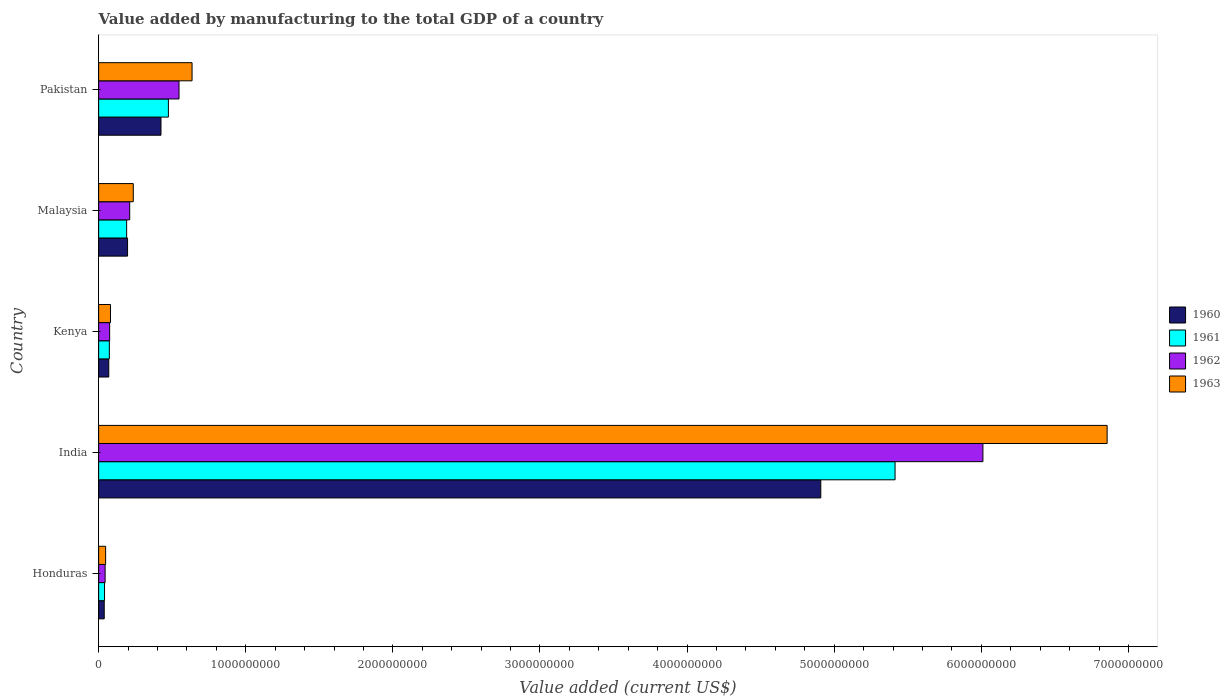How many different coloured bars are there?
Offer a very short reply. 4. How many groups of bars are there?
Provide a succinct answer. 5. How many bars are there on the 1st tick from the bottom?
Provide a short and direct response. 4. What is the label of the 2nd group of bars from the top?
Your answer should be compact. Malaysia. What is the value added by manufacturing to the total GDP in 1962 in Pakistan?
Make the answer very short. 5.46e+08. Across all countries, what is the maximum value added by manufacturing to the total GDP in 1960?
Keep it short and to the point. 4.91e+09. Across all countries, what is the minimum value added by manufacturing to the total GDP in 1961?
Keep it short and to the point. 4.00e+07. In which country was the value added by manufacturing to the total GDP in 1960 minimum?
Make the answer very short. Honduras. What is the total value added by manufacturing to the total GDP in 1961 in the graph?
Ensure brevity in your answer.  6.19e+09. What is the difference between the value added by manufacturing to the total GDP in 1963 in Kenya and that in Pakistan?
Your answer should be very brief. -5.54e+08. What is the difference between the value added by manufacturing to the total GDP in 1961 in Malaysia and the value added by manufacturing to the total GDP in 1960 in Kenya?
Make the answer very short. 1.21e+08. What is the average value added by manufacturing to the total GDP in 1962 per country?
Provide a succinct answer. 1.38e+09. What is the difference between the value added by manufacturing to the total GDP in 1962 and value added by manufacturing to the total GDP in 1963 in Malaysia?
Provide a short and direct response. -2.43e+07. In how many countries, is the value added by manufacturing to the total GDP in 1962 greater than 1600000000 US$?
Provide a succinct answer. 1. What is the ratio of the value added by manufacturing to the total GDP in 1960 in India to that in Malaysia?
Keep it short and to the point. 24.96. Is the value added by manufacturing to the total GDP in 1960 in India less than that in Pakistan?
Offer a terse response. No. What is the difference between the highest and the second highest value added by manufacturing to the total GDP in 1963?
Make the answer very short. 6.22e+09. What is the difference between the highest and the lowest value added by manufacturing to the total GDP in 1961?
Your answer should be very brief. 5.37e+09. What does the 3rd bar from the top in Pakistan represents?
Offer a terse response. 1961. What does the 2nd bar from the bottom in India represents?
Ensure brevity in your answer.  1961. Is it the case that in every country, the sum of the value added by manufacturing to the total GDP in 1961 and value added by manufacturing to the total GDP in 1963 is greater than the value added by manufacturing to the total GDP in 1962?
Provide a short and direct response. Yes. How many bars are there?
Keep it short and to the point. 20. How many countries are there in the graph?
Ensure brevity in your answer.  5. Does the graph contain any zero values?
Offer a terse response. No. Where does the legend appear in the graph?
Your answer should be compact. Center right. How many legend labels are there?
Offer a very short reply. 4. How are the legend labels stacked?
Your answer should be very brief. Vertical. What is the title of the graph?
Offer a very short reply. Value added by manufacturing to the total GDP of a country. What is the label or title of the X-axis?
Keep it short and to the point. Value added (current US$). What is the Value added (current US$) of 1960 in Honduras?
Give a very brief answer. 3.80e+07. What is the Value added (current US$) in 1961 in Honduras?
Your response must be concise. 4.00e+07. What is the Value added (current US$) of 1962 in Honduras?
Provide a succinct answer. 4.41e+07. What is the Value added (current US$) in 1963 in Honduras?
Keep it short and to the point. 4.76e+07. What is the Value added (current US$) of 1960 in India?
Provide a succinct answer. 4.91e+09. What is the Value added (current US$) in 1961 in India?
Make the answer very short. 5.41e+09. What is the Value added (current US$) in 1962 in India?
Provide a succinct answer. 6.01e+09. What is the Value added (current US$) in 1963 in India?
Offer a very short reply. 6.85e+09. What is the Value added (current US$) in 1960 in Kenya?
Provide a short and direct response. 6.89e+07. What is the Value added (current US$) in 1961 in Kenya?
Your answer should be very brief. 7.28e+07. What is the Value added (current US$) of 1962 in Kenya?
Offer a terse response. 7.48e+07. What is the Value added (current US$) in 1963 in Kenya?
Make the answer very short. 8.05e+07. What is the Value added (current US$) in 1960 in Malaysia?
Give a very brief answer. 1.97e+08. What is the Value added (current US$) in 1961 in Malaysia?
Your answer should be very brief. 1.90e+08. What is the Value added (current US$) in 1962 in Malaysia?
Your answer should be very brief. 2.11e+08. What is the Value added (current US$) of 1963 in Malaysia?
Provide a succinct answer. 2.36e+08. What is the Value added (current US$) in 1960 in Pakistan?
Ensure brevity in your answer.  4.24e+08. What is the Value added (current US$) in 1961 in Pakistan?
Make the answer very short. 4.74e+08. What is the Value added (current US$) of 1962 in Pakistan?
Give a very brief answer. 5.46e+08. What is the Value added (current US$) in 1963 in Pakistan?
Give a very brief answer. 6.35e+08. Across all countries, what is the maximum Value added (current US$) of 1960?
Your answer should be very brief. 4.91e+09. Across all countries, what is the maximum Value added (current US$) of 1961?
Make the answer very short. 5.41e+09. Across all countries, what is the maximum Value added (current US$) in 1962?
Keep it short and to the point. 6.01e+09. Across all countries, what is the maximum Value added (current US$) of 1963?
Provide a short and direct response. 6.85e+09. Across all countries, what is the minimum Value added (current US$) in 1960?
Offer a terse response. 3.80e+07. Across all countries, what is the minimum Value added (current US$) in 1961?
Offer a terse response. 4.00e+07. Across all countries, what is the minimum Value added (current US$) in 1962?
Offer a very short reply. 4.41e+07. Across all countries, what is the minimum Value added (current US$) in 1963?
Provide a succinct answer. 4.76e+07. What is the total Value added (current US$) of 1960 in the graph?
Offer a terse response. 5.64e+09. What is the total Value added (current US$) of 1961 in the graph?
Keep it short and to the point. 6.19e+09. What is the total Value added (current US$) in 1962 in the graph?
Provide a short and direct response. 6.89e+09. What is the total Value added (current US$) in 1963 in the graph?
Ensure brevity in your answer.  7.85e+09. What is the difference between the Value added (current US$) in 1960 in Honduras and that in India?
Your response must be concise. -4.87e+09. What is the difference between the Value added (current US$) in 1961 in Honduras and that in India?
Provide a short and direct response. -5.37e+09. What is the difference between the Value added (current US$) in 1962 in Honduras and that in India?
Your answer should be compact. -5.97e+09. What is the difference between the Value added (current US$) of 1963 in Honduras and that in India?
Offer a terse response. -6.81e+09. What is the difference between the Value added (current US$) in 1960 in Honduras and that in Kenya?
Make the answer very short. -3.09e+07. What is the difference between the Value added (current US$) in 1961 in Honduras and that in Kenya?
Your answer should be compact. -3.28e+07. What is the difference between the Value added (current US$) of 1962 in Honduras and that in Kenya?
Your answer should be very brief. -3.07e+07. What is the difference between the Value added (current US$) in 1963 in Honduras and that in Kenya?
Offer a terse response. -3.30e+07. What is the difference between the Value added (current US$) in 1960 in Honduras and that in Malaysia?
Make the answer very short. -1.59e+08. What is the difference between the Value added (current US$) in 1961 in Honduras and that in Malaysia?
Your answer should be compact. -1.50e+08. What is the difference between the Value added (current US$) in 1962 in Honduras and that in Malaysia?
Offer a terse response. -1.67e+08. What is the difference between the Value added (current US$) of 1963 in Honduras and that in Malaysia?
Offer a terse response. -1.88e+08. What is the difference between the Value added (current US$) of 1960 in Honduras and that in Pakistan?
Your answer should be compact. -3.86e+08. What is the difference between the Value added (current US$) of 1961 in Honduras and that in Pakistan?
Offer a terse response. -4.34e+08. What is the difference between the Value added (current US$) of 1962 in Honduras and that in Pakistan?
Offer a very short reply. -5.02e+08. What is the difference between the Value added (current US$) of 1963 in Honduras and that in Pakistan?
Provide a short and direct response. -5.87e+08. What is the difference between the Value added (current US$) in 1960 in India and that in Kenya?
Your answer should be very brief. 4.84e+09. What is the difference between the Value added (current US$) in 1961 in India and that in Kenya?
Give a very brief answer. 5.34e+09. What is the difference between the Value added (current US$) in 1962 in India and that in Kenya?
Keep it short and to the point. 5.94e+09. What is the difference between the Value added (current US$) in 1963 in India and that in Kenya?
Ensure brevity in your answer.  6.77e+09. What is the difference between the Value added (current US$) of 1960 in India and that in Malaysia?
Your answer should be very brief. 4.71e+09. What is the difference between the Value added (current US$) of 1961 in India and that in Malaysia?
Ensure brevity in your answer.  5.22e+09. What is the difference between the Value added (current US$) in 1962 in India and that in Malaysia?
Make the answer very short. 5.80e+09. What is the difference between the Value added (current US$) of 1963 in India and that in Malaysia?
Offer a very short reply. 6.62e+09. What is the difference between the Value added (current US$) in 1960 in India and that in Pakistan?
Offer a very short reply. 4.48e+09. What is the difference between the Value added (current US$) in 1961 in India and that in Pakistan?
Give a very brief answer. 4.94e+09. What is the difference between the Value added (current US$) of 1962 in India and that in Pakistan?
Ensure brevity in your answer.  5.46e+09. What is the difference between the Value added (current US$) of 1963 in India and that in Pakistan?
Give a very brief answer. 6.22e+09. What is the difference between the Value added (current US$) in 1960 in Kenya and that in Malaysia?
Ensure brevity in your answer.  -1.28e+08. What is the difference between the Value added (current US$) in 1961 in Kenya and that in Malaysia?
Make the answer very short. -1.18e+08. What is the difference between the Value added (current US$) of 1962 in Kenya and that in Malaysia?
Your answer should be very brief. -1.36e+08. What is the difference between the Value added (current US$) in 1963 in Kenya and that in Malaysia?
Ensure brevity in your answer.  -1.55e+08. What is the difference between the Value added (current US$) of 1960 in Kenya and that in Pakistan?
Ensure brevity in your answer.  -3.55e+08. What is the difference between the Value added (current US$) of 1961 in Kenya and that in Pakistan?
Your answer should be compact. -4.01e+08. What is the difference between the Value added (current US$) in 1962 in Kenya and that in Pakistan?
Your answer should be very brief. -4.72e+08. What is the difference between the Value added (current US$) of 1963 in Kenya and that in Pakistan?
Your response must be concise. -5.54e+08. What is the difference between the Value added (current US$) of 1960 in Malaysia and that in Pakistan?
Your answer should be compact. -2.27e+08. What is the difference between the Value added (current US$) of 1961 in Malaysia and that in Pakistan?
Make the answer very short. -2.84e+08. What is the difference between the Value added (current US$) of 1962 in Malaysia and that in Pakistan?
Provide a succinct answer. -3.35e+08. What is the difference between the Value added (current US$) in 1963 in Malaysia and that in Pakistan?
Offer a very short reply. -3.99e+08. What is the difference between the Value added (current US$) in 1960 in Honduras and the Value added (current US$) in 1961 in India?
Give a very brief answer. -5.38e+09. What is the difference between the Value added (current US$) in 1960 in Honduras and the Value added (current US$) in 1962 in India?
Offer a very short reply. -5.97e+09. What is the difference between the Value added (current US$) in 1960 in Honduras and the Value added (current US$) in 1963 in India?
Give a very brief answer. -6.82e+09. What is the difference between the Value added (current US$) in 1961 in Honduras and the Value added (current US$) in 1962 in India?
Offer a terse response. -5.97e+09. What is the difference between the Value added (current US$) of 1961 in Honduras and the Value added (current US$) of 1963 in India?
Offer a very short reply. -6.81e+09. What is the difference between the Value added (current US$) in 1962 in Honduras and the Value added (current US$) in 1963 in India?
Your answer should be very brief. -6.81e+09. What is the difference between the Value added (current US$) in 1960 in Honduras and the Value added (current US$) in 1961 in Kenya?
Provide a succinct answer. -3.48e+07. What is the difference between the Value added (current US$) of 1960 in Honduras and the Value added (current US$) of 1962 in Kenya?
Your response must be concise. -3.68e+07. What is the difference between the Value added (current US$) in 1960 in Honduras and the Value added (current US$) in 1963 in Kenya?
Your response must be concise. -4.25e+07. What is the difference between the Value added (current US$) in 1961 in Honduras and the Value added (current US$) in 1962 in Kenya?
Provide a short and direct response. -3.48e+07. What is the difference between the Value added (current US$) of 1961 in Honduras and the Value added (current US$) of 1963 in Kenya?
Your answer should be very brief. -4.05e+07. What is the difference between the Value added (current US$) of 1962 in Honduras and the Value added (current US$) of 1963 in Kenya?
Keep it short and to the point. -3.64e+07. What is the difference between the Value added (current US$) of 1960 in Honduras and the Value added (current US$) of 1961 in Malaysia?
Your response must be concise. -1.52e+08. What is the difference between the Value added (current US$) of 1960 in Honduras and the Value added (current US$) of 1962 in Malaysia?
Provide a succinct answer. -1.73e+08. What is the difference between the Value added (current US$) in 1960 in Honduras and the Value added (current US$) in 1963 in Malaysia?
Your answer should be very brief. -1.97e+08. What is the difference between the Value added (current US$) in 1961 in Honduras and the Value added (current US$) in 1962 in Malaysia?
Your response must be concise. -1.71e+08. What is the difference between the Value added (current US$) of 1961 in Honduras and the Value added (current US$) of 1963 in Malaysia?
Make the answer very short. -1.95e+08. What is the difference between the Value added (current US$) in 1962 in Honduras and the Value added (current US$) in 1963 in Malaysia?
Provide a short and direct response. -1.91e+08. What is the difference between the Value added (current US$) in 1960 in Honduras and the Value added (current US$) in 1961 in Pakistan?
Give a very brief answer. -4.36e+08. What is the difference between the Value added (current US$) in 1960 in Honduras and the Value added (current US$) in 1962 in Pakistan?
Your answer should be very brief. -5.08e+08. What is the difference between the Value added (current US$) in 1960 in Honduras and the Value added (current US$) in 1963 in Pakistan?
Offer a very short reply. -5.97e+08. What is the difference between the Value added (current US$) in 1961 in Honduras and the Value added (current US$) in 1962 in Pakistan?
Offer a terse response. -5.06e+08. What is the difference between the Value added (current US$) in 1961 in Honduras and the Value added (current US$) in 1963 in Pakistan?
Make the answer very short. -5.95e+08. What is the difference between the Value added (current US$) in 1962 in Honduras and the Value added (current US$) in 1963 in Pakistan?
Give a very brief answer. -5.91e+08. What is the difference between the Value added (current US$) of 1960 in India and the Value added (current US$) of 1961 in Kenya?
Keep it short and to the point. 4.84e+09. What is the difference between the Value added (current US$) of 1960 in India and the Value added (current US$) of 1962 in Kenya?
Ensure brevity in your answer.  4.83e+09. What is the difference between the Value added (current US$) of 1960 in India and the Value added (current US$) of 1963 in Kenya?
Give a very brief answer. 4.83e+09. What is the difference between the Value added (current US$) in 1961 in India and the Value added (current US$) in 1962 in Kenya?
Provide a succinct answer. 5.34e+09. What is the difference between the Value added (current US$) in 1961 in India and the Value added (current US$) in 1963 in Kenya?
Offer a very short reply. 5.33e+09. What is the difference between the Value added (current US$) in 1962 in India and the Value added (current US$) in 1963 in Kenya?
Offer a terse response. 5.93e+09. What is the difference between the Value added (current US$) of 1960 in India and the Value added (current US$) of 1961 in Malaysia?
Ensure brevity in your answer.  4.72e+09. What is the difference between the Value added (current US$) of 1960 in India and the Value added (current US$) of 1962 in Malaysia?
Ensure brevity in your answer.  4.70e+09. What is the difference between the Value added (current US$) in 1960 in India and the Value added (current US$) in 1963 in Malaysia?
Offer a terse response. 4.67e+09. What is the difference between the Value added (current US$) in 1961 in India and the Value added (current US$) in 1962 in Malaysia?
Provide a succinct answer. 5.20e+09. What is the difference between the Value added (current US$) of 1961 in India and the Value added (current US$) of 1963 in Malaysia?
Your answer should be compact. 5.18e+09. What is the difference between the Value added (current US$) in 1962 in India and the Value added (current US$) in 1963 in Malaysia?
Your response must be concise. 5.78e+09. What is the difference between the Value added (current US$) of 1960 in India and the Value added (current US$) of 1961 in Pakistan?
Offer a terse response. 4.43e+09. What is the difference between the Value added (current US$) of 1960 in India and the Value added (current US$) of 1962 in Pakistan?
Your answer should be compact. 4.36e+09. What is the difference between the Value added (current US$) in 1960 in India and the Value added (current US$) in 1963 in Pakistan?
Provide a succinct answer. 4.27e+09. What is the difference between the Value added (current US$) in 1961 in India and the Value added (current US$) in 1962 in Pakistan?
Your response must be concise. 4.87e+09. What is the difference between the Value added (current US$) of 1961 in India and the Value added (current US$) of 1963 in Pakistan?
Make the answer very short. 4.78e+09. What is the difference between the Value added (current US$) of 1962 in India and the Value added (current US$) of 1963 in Pakistan?
Provide a short and direct response. 5.38e+09. What is the difference between the Value added (current US$) in 1960 in Kenya and the Value added (current US$) in 1961 in Malaysia?
Your response must be concise. -1.21e+08. What is the difference between the Value added (current US$) of 1960 in Kenya and the Value added (current US$) of 1962 in Malaysia?
Your response must be concise. -1.42e+08. What is the difference between the Value added (current US$) of 1960 in Kenya and the Value added (current US$) of 1963 in Malaysia?
Offer a very short reply. -1.67e+08. What is the difference between the Value added (current US$) in 1961 in Kenya and the Value added (current US$) in 1962 in Malaysia?
Give a very brief answer. -1.38e+08. What is the difference between the Value added (current US$) in 1961 in Kenya and the Value added (current US$) in 1963 in Malaysia?
Offer a terse response. -1.63e+08. What is the difference between the Value added (current US$) of 1962 in Kenya and the Value added (current US$) of 1963 in Malaysia?
Offer a terse response. -1.61e+08. What is the difference between the Value added (current US$) of 1960 in Kenya and the Value added (current US$) of 1961 in Pakistan?
Provide a short and direct response. -4.05e+08. What is the difference between the Value added (current US$) in 1960 in Kenya and the Value added (current US$) in 1962 in Pakistan?
Ensure brevity in your answer.  -4.78e+08. What is the difference between the Value added (current US$) of 1960 in Kenya and the Value added (current US$) of 1963 in Pakistan?
Provide a short and direct response. -5.66e+08. What is the difference between the Value added (current US$) in 1961 in Kenya and the Value added (current US$) in 1962 in Pakistan?
Give a very brief answer. -4.74e+08. What is the difference between the Value added (current US$) in 1961 in Kenya and the Value added (current US$) in 1963 in Pakistan?
Make the answer very short. -5.62e+08. What is the difference between the Value added (current US$) in 1962 in Kenya and the Value added (current US$) in 1963 in Pakistan?
Offer a very short reply. -5.60e+08. What is the difference between the Value added (current US$) of 1960 in Malaysia and the Value added (current US$) of 1961 in Pakistan?
Give a very brief answer. -2.78e+08. What is the difference between the Value added (current US$) of 1960 in Malaysia and the Value added (current US$) of 1962 in Pakistan?
Offer a very short reply. -3.50e+08. What is the difference between the Value added (current US$) of 1960 in Malaysia and the Value added (current US$) of 1963 in Pakistan?
Offer a terse response. -4.38e+08. What is the difference between the Value added (current US$) of 1961 in Malaysia and the Value added (current US$) of 1962 in Pakistan?
Your response must be concise. -3.56e+08. What is the difference between the Value added (current US$) of 1961 in Malaysia and the Value added (current US$) of 1963 in Pakistan?
Your answer should be compact. -4.45e+08. What is the difference between the Value added (current US$) of 1962 in Malaysia and the Value added (current US$) of 1963 in Pakistan?
Make the answer very short. -4.24e+08. What is the average Value added (current US$) in 1960 per country?
Ensure brevity in your answer.  1.13e+09. What is the average Value added (current US$) of 1961 per country?
Give a very brief answer. 1.24e+09. What is the average Value added (current US$) of 1962 per country?
Provide a succinct answer. 1.38e+09. What is the average Value added (current US$) in 1963 per country?
Your response must be concise. 1.57e+09. What is the difference between the Value added (current US$) of 1960 and Value added (current US$) of 1961 in Honduras?
Provide a short and direct response. -2.00e+06. What is the difference between the Value added (current US$) of 1960 and Value added (current US$) of 1962 in Honduras?
Offer a terse response. -6.05e+06. What is the difference between the Value added (current US$) in 1960 and Value added (current US$) in 1963 in Honduras?
Offer a very short reply. -9.50e+06. What is the difference between the Value added (current US$) in 1961 and Value added (current US$) in 1962 in Honduras?
Keep it short and to the point. -4.05e+06. What is the difference between the Value added (current US$) in 1961 and Value added (current US$) in 1963 in Honduras?
Offer a very short reply. -7.50e+06. What is the difference between the Value added (current US$) of 1962 and Value added (current US$) of 1963 in Honduras?
Your answer should be very brief. -3.45e+06. What is the difference between the Value added (current US$) in 1960 and Value added (current US$) in 1961 in India?
Make the answer very short. -5.05e+08. What is the difference between the Value added (current US$) in 1960 and Value added (current US$) in 1962 in India?
Give a very brief answer. -1.10e+09. What is the difference between the Value added (current US$) of 1960 and Value added (current US$) of 1963 in India?
Ensure brevity in your answer.  -1.95e+09. What is the difference between the Value added (current US$) of 1961 and Value added (current US$) of 1962 in India?
Provide a short and direct response. -5.97e+08. What is the difference between the Value added (current US$) in 1961 and Value added (current US$) in 1963 in India?
Your answer should be compact. -1.44e+09. What is the difference between the Value added (current US$) in 1962 and Value added (current US$) in 1963 in India?
Offer a very short reply. -8.44e+08. What is the difference between the Value added (current US$) in 1960 and Value added (current US$) in 1961 in Kenya?
Offer a very short reply. -3.93e+06. What is the difference between the Value added (current US$) of 1960 and Value added (current US$) of 1962 in Kenya?
Your answer should be very brief. -5.94e+06. What is the difference between the Value added (current US$) in 1960 and Value added (current US$) in 1963 in Kenya?
Ensure brevity in your answer.  -1.16e+07. What is the difference between the Value added (current US$) in 1961 and Value added (current US$) in 1962 in Kenya?
Make the answer very short. -2.00e+06. What is the difference between the Value added (current US$) of 1961 and Value added (current US$) of 1963 in Kenya?
Provide a succinct answer. -7.70e+06. What is the difference between the Value added (current US$) of 1962 and Value added (current US$) of 1963 in Kenya?
Make the answer very short. -5.70e+06. What is the difference between the Value added (current US$) of 1960 and Value added (current US$) of 1961 in Malaysia?
Give a very brief answer. 6.25e+06. What is the difference between the Value added (current US$) in 1960 and Value added (current US$) in 1962 in Malaysia?
Offer a terse response. -1.46e+07. What is the difference between the Value added (current US$) in 1960 and Value added (current US$) in 1963 in Malaysia?
Your answer should be very brief. -3.89e+07. What is the difference between the Value added (current US$) in 1961 and Value added (current US$) in 1962 in Malaysia?
Your response must be concise. -2.08e+07. What is the difference between the Value added (current US$) in 1961 and Value added (current US$) in 1963 in Malaysia?
Make the answer very short. -4.52e+07. What is the difference between the Value added (current US$) of 1962 and Value added (current US$) of 1963 in Malaysia?
Your answer should be compact. -2.43e+07. What is the difference between the Value added (current US$) of 1960 and Value added (current US$) of 1961 in Pakistan?
Make the answer very short. -5.04e+07. What is the difference between the Value added (current US$) in 1960 and Value added (current US$) in 1962 in Pakistan?
Offer a very short reply. -1.23e+08. What is the difference between the Value added (current US$) of 1960 and Value added (current US$) of 1963 in Pakistan?
Offer a very short reply. -2.11e+08. What is the difference between the Value added (current US$) of 1961 and Value added (current US$) of 1962 in Pakistan?
Offer a terse response. -7.22e+07. What is the difference between the Value added (current US$) in 1961 and Value added (current US$) in 1963 in Pakistan?
Offer a very short reply. -1.61e+08. What is the difference between the Value added (current US$) of 1962 and Value added (current US$) of 1963 in Pakistan?
Your answer should be very brief. -8.86e+07. What is the ratio of the Value added (current US$) in 1960 in Honduras to that in India?
Offer a terse response. 0.01. What is the ratio of the Value added (current US$) in 1961 in Honduras to that in India?
Keep it short and to the point. 0.01. What is the ratio of the Value added (current US$) of 1962 in Honduras to that in India?
Give a very brief answer. 0.01. What is the ratio of the Value added (current US$) in 1963 in Honduras to that in India?
Provide a short and direct response. 0.01. What is the ratio of the Value added (current US$) in 1960 in Honduras to that in Kenya?
Offer a terse response. 0.55. What is the ratio of the Value added (current US$) of 1961 in Honduras to that in Kenya?
Provide a succinct answer. 0.55. What is the ratio of the Value added (current US$) of 1962 in Honduras to that in Kenya?
Give a very brief answer. 0.59. What is the ratio of the Value added (current US$) in 1963 in Honduras to that in Kenya?
Provide a succinct answer. 0.59. What is the ratio of the Value added (current US$) in 1960 in Honduras to that in Malaysia?
Your answer should be very brief. 0.19. What is the ratio of the Value added (current US$) of 1961 in Honduras to that in Malaysia?
Make the answer very short. 0.21. What is the ratio of the Value added (current US$) of 1962 in Honduras to that in Malaysia?
Keep it short and to the point. 0.21. What is the ratio of the Value added (current US$) of 1963 in Honduras to that in Malaysia?
Your answer should be very brief. 0.2. What is the ratio of the Value added (current US$) in 1960 in Honduras to that in Pakistan?
Your response must be concise. 0.09. What is the ratio of the Value added (current US$) of 1961 in Honduras to that in Pakistan?
Give a very brief answer. 0.08. What is the ratio of the Value added (current US$) of 1962 in Honduras to that in Pakistan?
Offer a very short reply. 0.08. What is the ratio of the Value added (current US$) of 1963 in Honduras to that in Pakistan?
Ensure brevity in your answer.  0.07. What is the ratio of the Value added (current US$) of 1960 in India to that in Kenya?
Provide a short and direct response. 71.24. What is the ratio of the Value added (current US$) in 1961 in India to that in Kenya?
Offer a terse response. 74.32. What is the ratio of the Value added (current US$) in 1962 in India to that in Kenya?
Make the answer very short. 80.31. What is the ratio of the Value added (current US$) in 1963 in India to that in Kenya?
Your answer should be very brief. 85.11. What is the ratio of the Value added (current US$) in 1960 in India to that in Malaysia?
Ensure brevity in your answer.  24.96. What is the ratio of the Value added (current US$) of 1961 in India to that in Malaysia?
Your response must be concise. 28.44. What is the ratio of the Value added (current US$) in 1962 in India to that in Malaysia?
Your answer should be compact. 28.46. What is the ratio of the Value added (current US$) of 1963 in India to that in Malaysia?
Offer a very short reply. 29.1. What is the ratio of the Value added (current US$) in 1960 in India to that in Pakistan?
Your answer should be very brief. 11.58. What is the ratio of the Value added (current US$) of 1961 in India to that in Pakistan?
Your answer should be compact. 11.42. What is the ratio of the Value added (current US$) of 1962 in India to that in Pakistan?
Offer a very short reply. 11. What is the ratio of the Value added (current US$) in 1963 in India to that in Pakistan?
Make the answer very short. 10.79. What is the ratio of the Value added (current US$) of 1960 in Kenya to that in Malaysia?
Make the answer very short. 0.35. What is the ratio of the Value added (current US$) of 1961 in Kenya to that in Malaysia?
Provide a short and direct response. 0.38. What is the ratio of the Value added (current US$) of 1962 in Kenya to that in Malaysia?
Your response must be concise. 0.35. What is the ratio of the Value added (current US$) of 1963 in Kenya to that in Malaysia?
Your answer should be very brief. 0.34. What is the ratio of the Value added (current US$) in 1960 in Kenya to that in Pakistan?
Provide a succinct answer. 0.16. What is the ratio of the Value added (current US$) in 1961 in Kenya to that in Pakistan?
Your answer should be very brief. 0.15. What is the ratio of the Value added (current US$) of 1962 in Kenya to that in Pakistan?
Your response must be concise. 0.14. What is the ratio of the Value added (current US$) of 1963 in Kenya to that in Pakistan?
Give a very brief answer. 0.13. What is the ratio of the Value added (current US$) in 1960 in Malaysia to that in Pakistan?
Provide a short and direct response. 0.46. What is the ratio of the Value added (current US$) in 1961 in Malaysia to that in Pakistan?
Make the answer very short. 0.4. What is the ratio of the Value added (current US$) in 1962 in Malaysia to that in Pakistan?
Provide a succinct answer. 0.39. What is the ratio of the Value added (current US$) of 1963 in Malaysia to that in Pakistan?
Provide a succinct answer. 0.37. What is the difference between the highest and the second highest Value added (current US$) in 1960?
Keep it short and to the point. 4.48e+09. What is the difference between the highest and the second highest Value added (current US$) in 1961?
Keep it short and to the point. 4.94e+09. What is the difference between the highest and the second highest Value added (current US$) in 1962?
Keep it short and to the point. 5.46e+09. What is the difference between the highest and the second highest Value added (current US$) in 1963?
Your answer should be compact. 6.22e+09. What is the difference between the highest and the lowest Value added (current US$) of 1960?
Offer a terse response. 4.87e+09. What is the difference between the highest and the lowest Value added (current US$) in 1961?
Your response must be concise. 5.37e+09. What is the difference between the highest and the lowest Value added (current US$) in 1962?
Keep it short and to the point. 5.97e+09. What is the difference between the highest and the lowest Value added (current US$) in 1963?
Provide a short and direct response. 6.81e+09. 